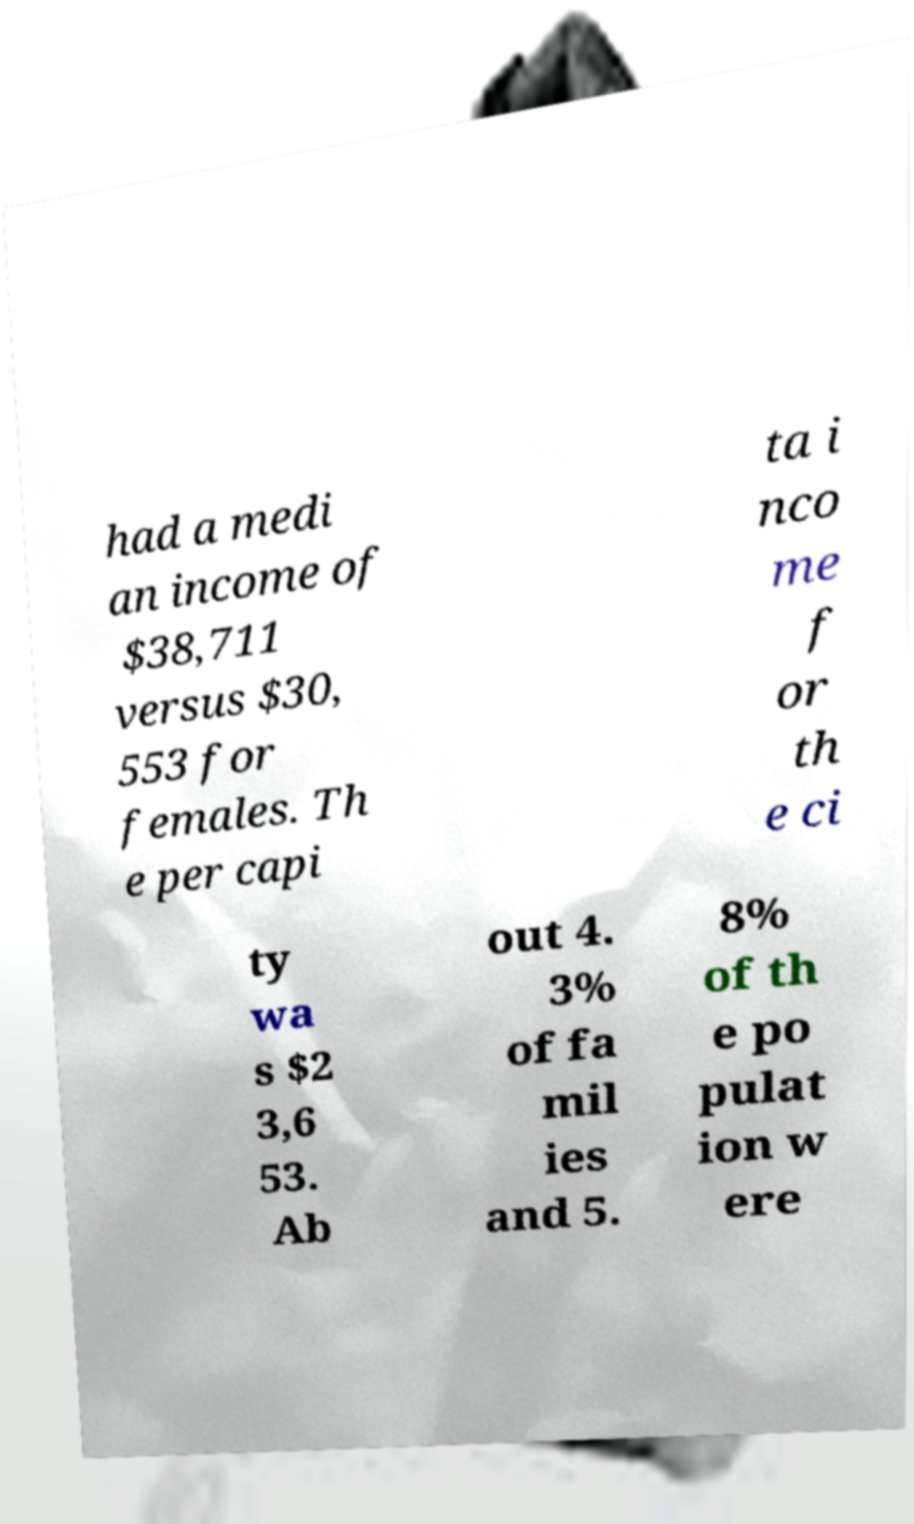Please identify and transcribe the text found in this image. had a medi an income of $38,711 versus $30, 553 for females. Th e per capi ta i nco me f or th e ci ty wa s $2 3,6 53. Ab out 4. 3% of fa mil ies and 5. 8% of th e po pulat ion w ere 